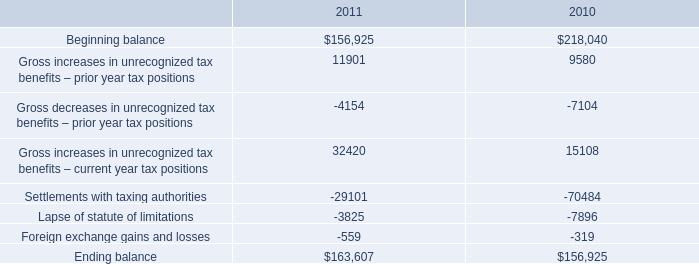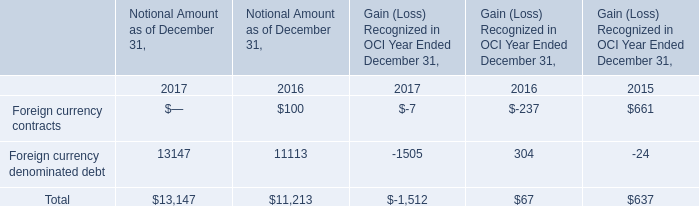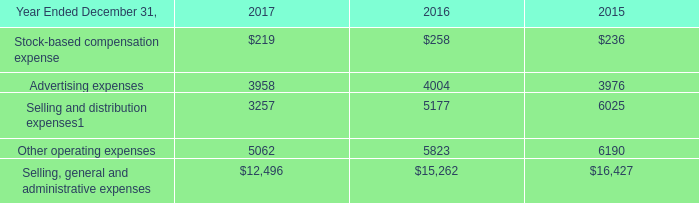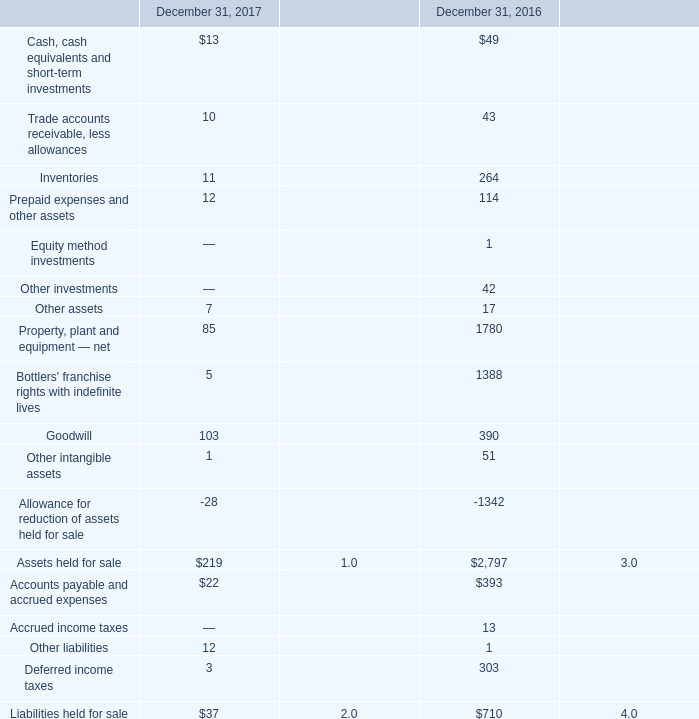What's the sum of Beginning balance of 2010, and Property, plant and equipment — net of December 31, 2016 ? 
Computations: (218040.0 + 1780.0)
Answer: 219820.0. 